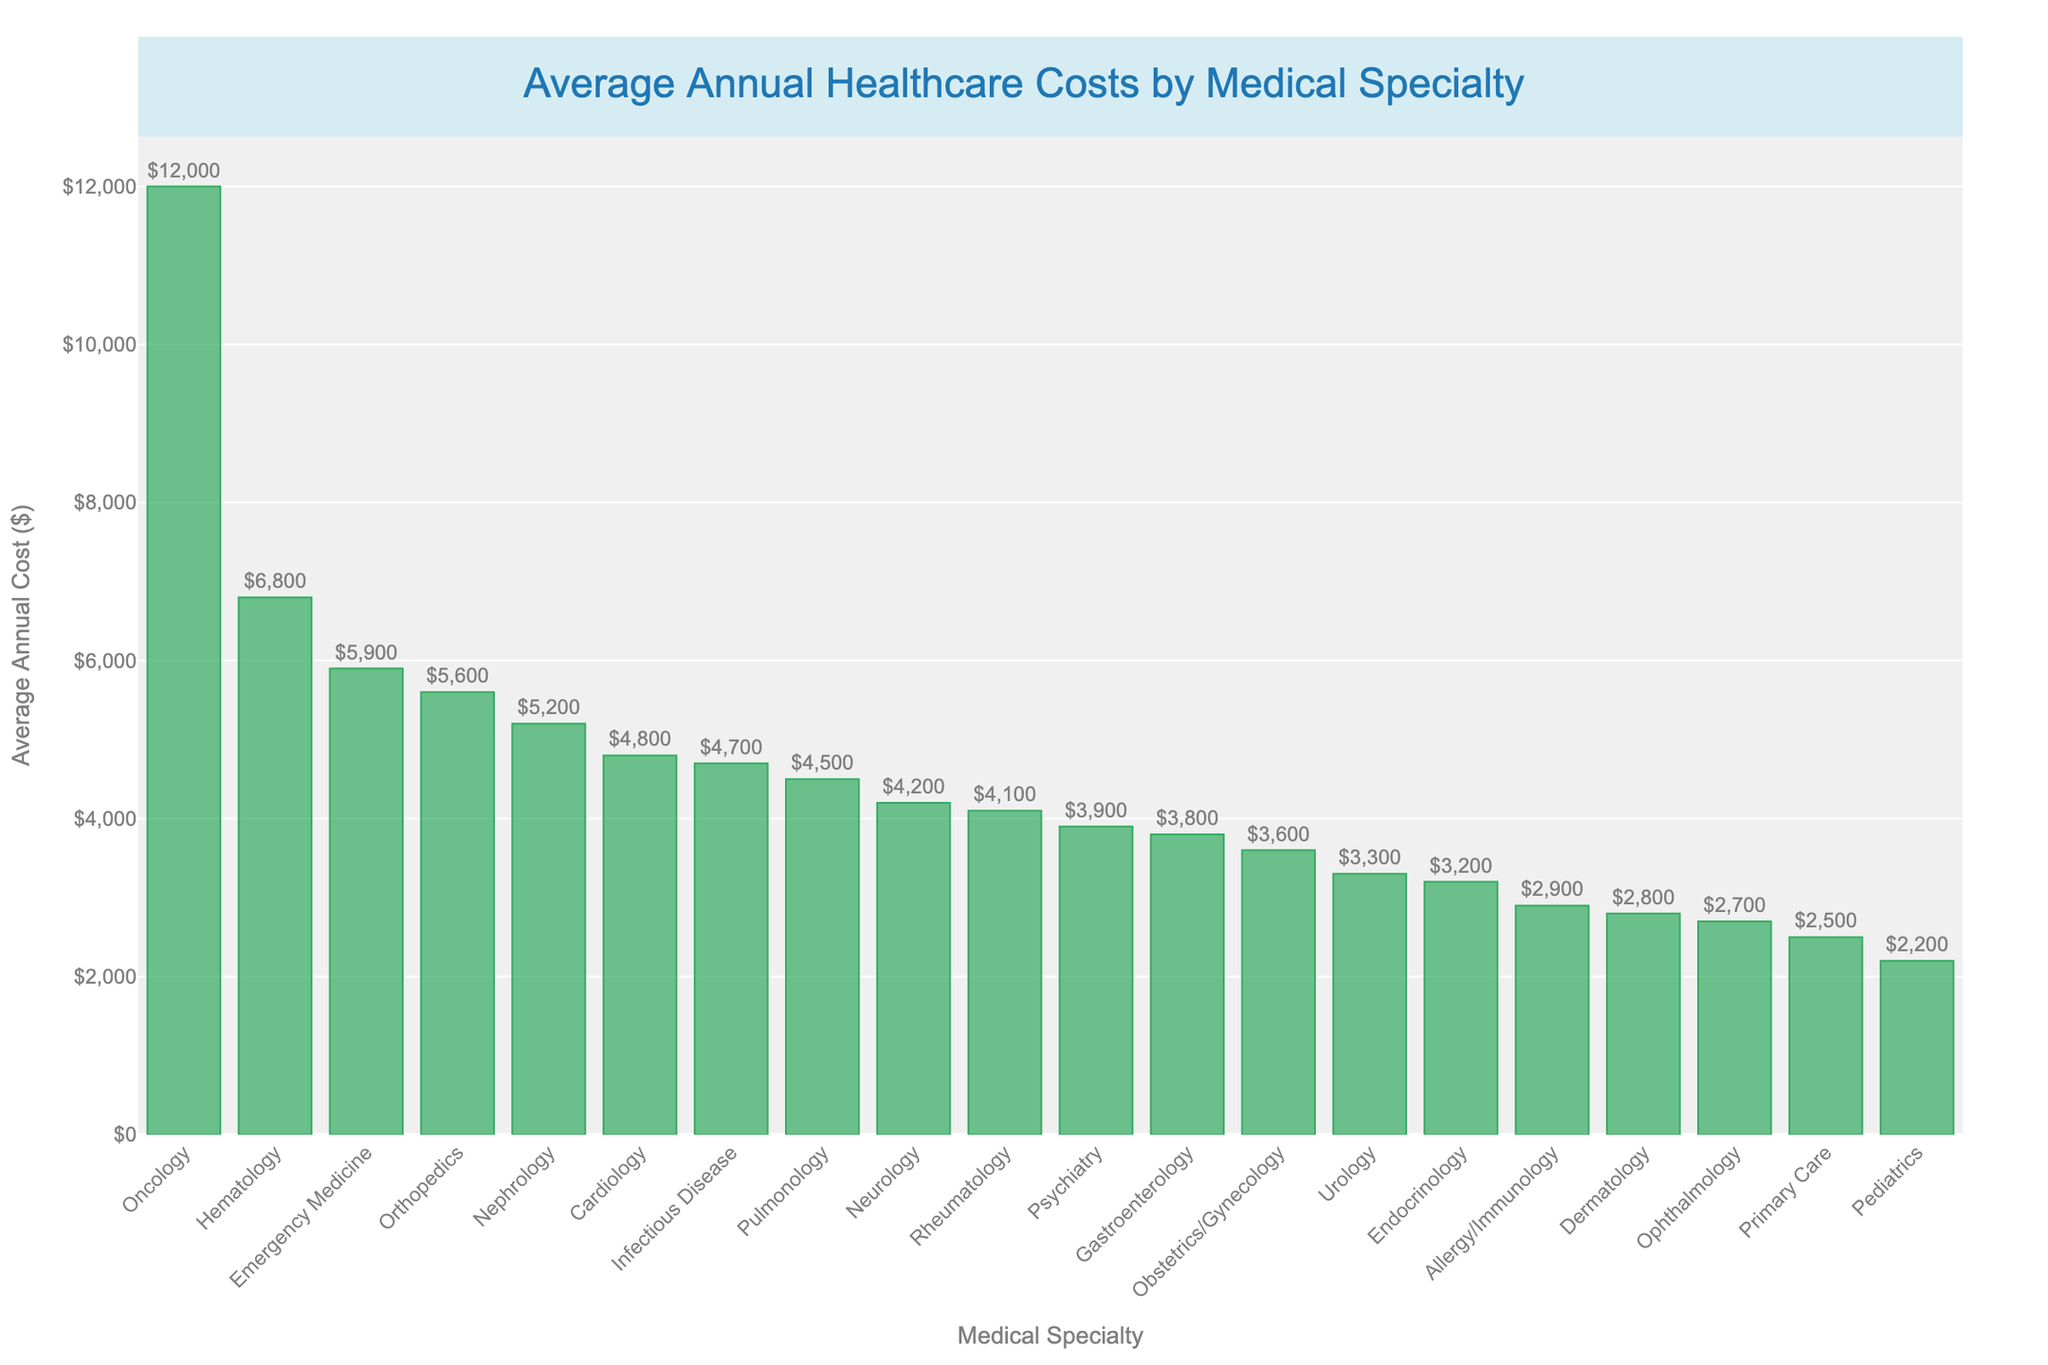Which medical specialty has the highest average annual cost? The highest bar in the figure corresponds to Oncology, indicating it has the highest average annual cost.
Answer: Oncology Which medical specialty has the lowest average annual cost? The shortest bar in the figure corresponds to Pediatrics, indicating it has the lowest average annual cost.
Answer: Pediatrics What is the difference in average annual cost between Oncology and Cardiology? Oncology's average annual cost is $12,000, and Cardiology's is $4,800. The difference is $12,000 - $4,800 = $7,200.
Answer: $7,200 How many medical specialties have an average annual cost greater than $5,000? The bars exceeding the $5,000 mark are for Oncology, Orthopedics, Emergency Medicine, Nephrology, and Hematology. Counting these, there are 5 specialties.
Answer: 5 What is the average annual cost of Endocrinology compared to Dermatology? Endocrinology has an average annual cost of $3,200, while Dermatology's is $2,800. Therefore, Endocrinology costs $400 more annually than Dermatology.
Answer: $400 more How does the average annual cost of Pulmonology compare to that of Gastroenterology? The average annual cost of Pulmonology is $4,500, and for Gastroenterology, it is $3,800. Pulmonology costs $700 more per year.
Answer: $700 more Which specialty has a higher average cost: Psychiatry or Rheumatology? Psychiatry's bar shows an average annual cost of $3,900, while Rheumatology's bar shows $4,100. Rheumatology has a higher cost.
Answer: Rheumatology If you combined the average annual costs of Neurology and Dermatology, what would be the total? Neurology's cost is $4,200, and Dermatology's is $2,800. Summing these, the total is $4,200 + $2,800 = $7,000.
Answer: $7,000 What is the range of average annual costs across all medical specialties? The range is calculated by subtracting the lowest cost (Pediatrics at $2,200) from the highest cost (Oncology at $12,000). The range is $12,000 - $2,200 = $9,800.
Answer: $9,800 Which specialties have an average annual cost within $200 of each other? The specialties with average annual costs within $200 of each other are Gastroenterology ($3,800) and Psychiatry ($3,900).
Answer: Gastroenterology and Psychiatry 